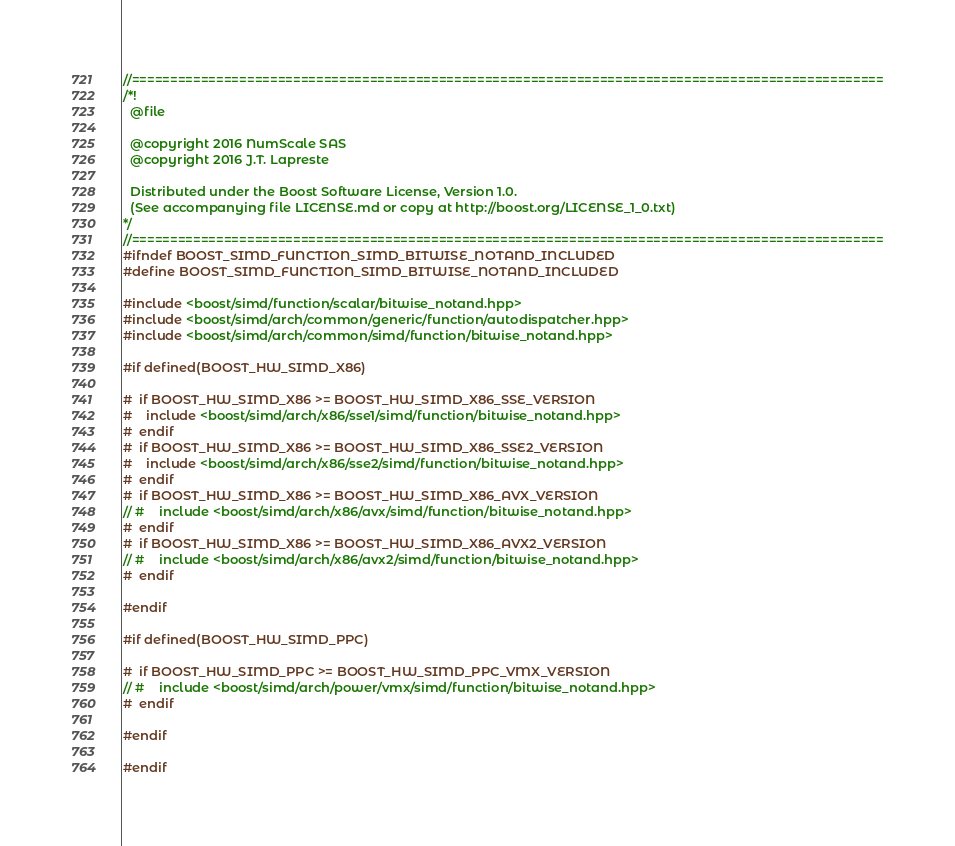Convert code to text. <code><loc_0><loc_0><loc_500><loc_500><_C++_>//==================================================================================================
/*!
  @file

  @copyright 2016 NumScale SAS
  @copyright 2016 J.T. Lapreste

  Distributed under the Boost Software License, Version 1.0.
  (See accompanying file LICENSE.md or copy at http://boost.org/LICENSE_1_0.txt)
*/
//==================================================================================================
#ifndef BOOST_SIMD_FUNCTION_SIMD_BITWISE_NOTAND_INCLUDED
#define BOOST_SIMD_FUNCTION_SIMD_BITWISE_NOTAND_INCLUDED

#include <boost/simd/function/scalar/bitwise_notand.hpp>
#include <boost/simd/arch/common/generic/function/autodispatcher.hpp>
#include <boost/simd/arch/common/simd/function/bitwise_notand.hpp>

#if defined(BOOST_HW_SIMD_X86)

#  if BOOST_HW_SIMD_X86 >= BOOST_HW_SIMD_X86_SSE_VERSION
#    include <boost/simd/arch/x86/sse1/simd/function/bitwise_notand.hpp>
#  endif
#  if BOOST_HW_SIMD_X86 >= BOOST_HW_SIMD_X86_SSE2_VERSION
#    include <boost/simd/arch/x86/sse2/simd/function/bitwise_notand.hpp>
#  endif
#  if BOOST_HW_SIMD_X86 >= BOOST_HW_SIMD_X86_AVX_VERSION
// #    include <boost/simd/arch/x86/avx/simd/function/bitwise_notand.hpp>
#  endif
#  if BOOST_HW_SIMD_X86 >= BOOST_HW_SIMD_X86_AVX2_VERSION
// #    include <boost/simd/arch/x86/avx2/simd/function/bitwise_notand.hpp>
#  endif

#endif

#if defined(BOOST_HW_SIMD_PPC)

#  if BOOST_HW_SIMD_PPC >= BOOST_HW_SIMD_PPC_VMX_VERSION
// #    include <boost/simd/arch/power/vmx/simd/function/bitwise_notand.hpp>
#  endif

#endif

#endif
</code> 